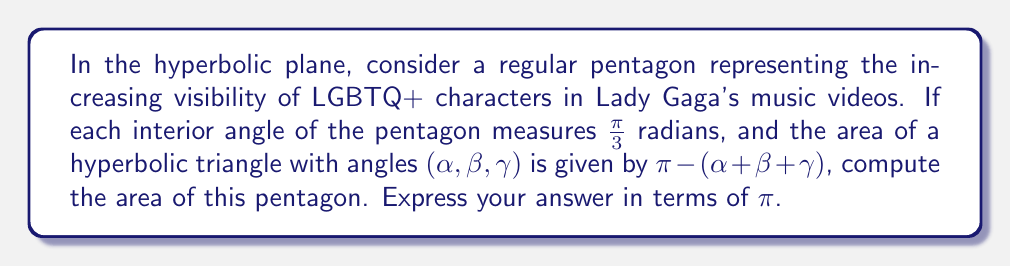Solve this math problem. Let's approach this step-by-step:

1) In a hyperbolic pentagon, the sum of interior angles is less than $3\pi$ radians (unlike in Euclidean geometry where it would be exactly $3\pi$).

2) We're given that each interior angle measures $\frac{\pi}{3}$ radians. So the sum of all interior angles is:

   $$5 \cdot \frac{\pi}{3} = \frac{5\pi}{3}$$

3) To find the area, we can divide the pentagon into three triangles by drawing two diagonals from one vertex.

4) In a hyperbolic triangle, the area is given by $\pi - (\alpha + \beta + \gamma)$, where $\alpha$, $\beta$, and $\gamma$ are the angles of the triangle.

5) The sum of the angles in our three triangles equals the sum of the pentagon's interior angles plus $2\pi$ (due to the two complete rotations at the central vertex where the diagonals meet):

   $$\frac{5\pi}{3} + 2\pi = \frac{11\pi}{3}$$

6) Therefore, the total area of the pentagon is:

   $$3\pi - \frac{11\pi}{3} = \frac{9\pi}{3} - \frac{11\pi}{3} = -\frac{2\pi}{3}$$

7) However, area is always positive, so we take the absolute value:

   $$\text{Area} = \left|\-\frac{2\pi}{3}\right| = \frac{2\pi}{3}$$

This represents how the expansion of LGBTQ+ representation in Lady Gaga's videos (symbolized by the pentagon) creates a space (area) in the media landscape (hyperbolic plane) that defies conventional (Euclidean) expectations.
Answer: $\frac{2\pi}{3}$ 